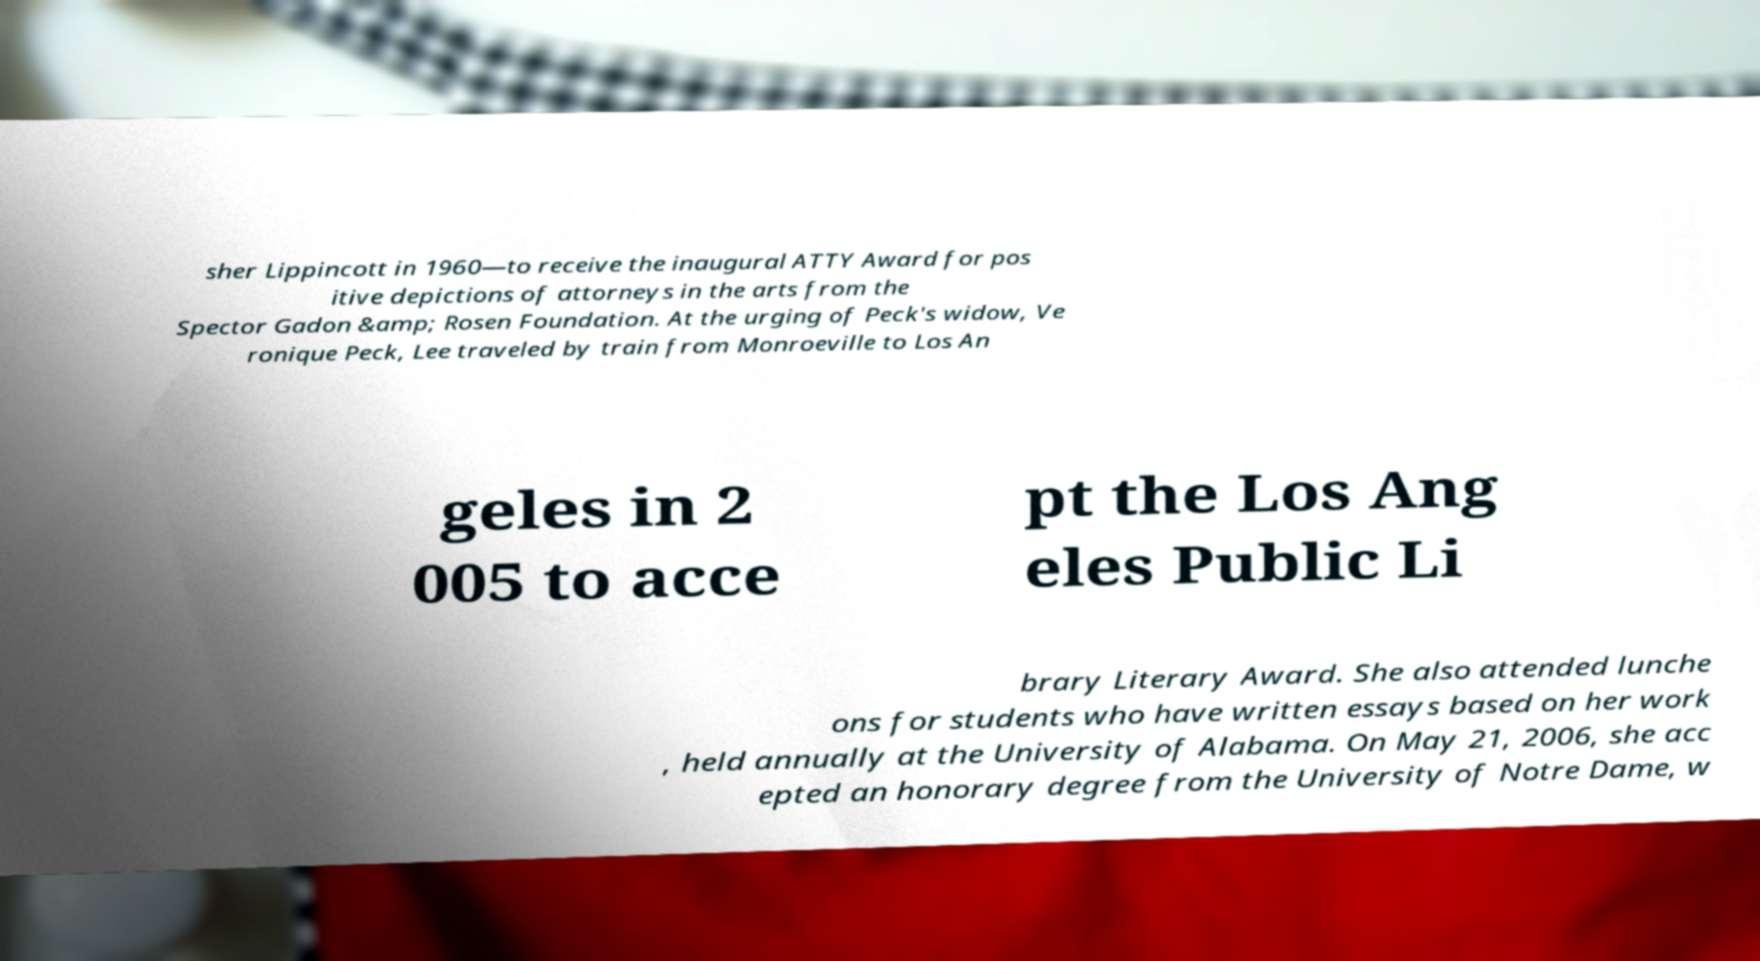Please identify and transcribe the text found in this image. sher Lippincott in 1960—to receive the inaugural ATTY Award for pos itive depictions of attorneys in the arts from the Spector Gadon &amp; Rosen Foundation. At the urging of Peck's widow, Ve ronique Peck, Lee traveled by train from Monroeville to Los An geles in 2 005 to acce pt the Los Ang eles Public Li brary Literary Award. She also attended lunche ons for students who have written essays based on her work , held annually at the University of Alabama. On May 21, 2006, she acc epted an honorary degree from the University of Notre Dame, w 